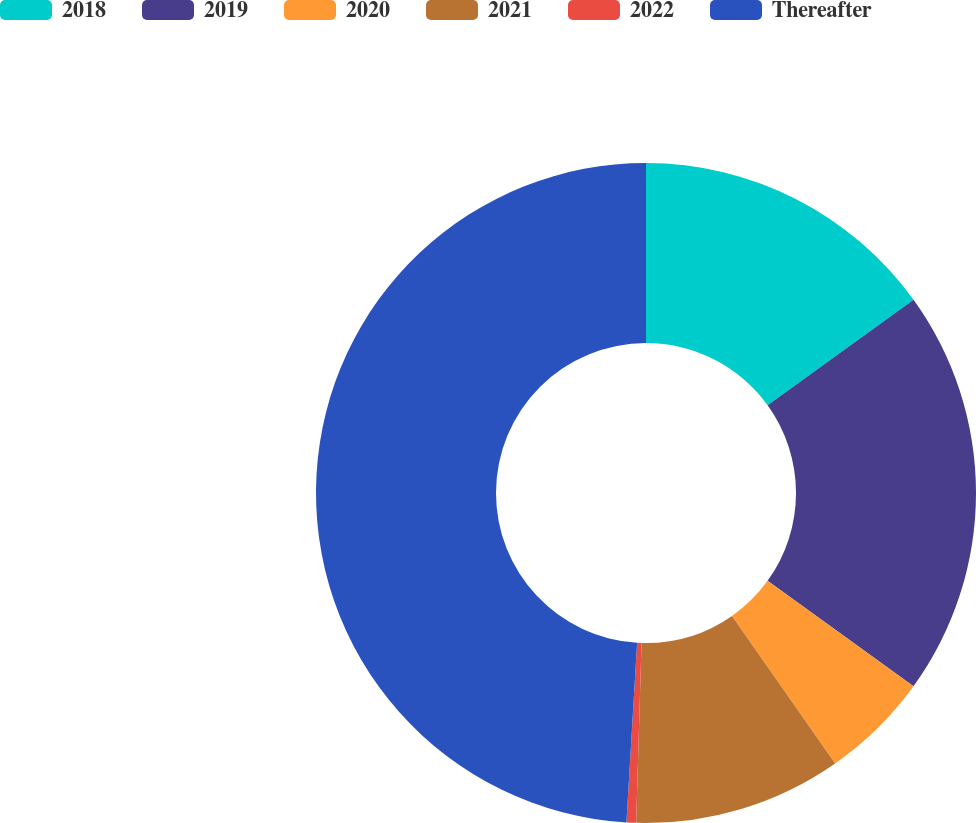<chart> <loc_0><loc_0><loc_500><loc_500><pie_chart><fcel>2018<fcel>2019<fcel>2020<fcel>2021<fcel>2022<fcel>Thereafter<nl><fcel>15.05%<fcel>19.91%<fcel>5.33%<fcel>10.19%<fcel>0.47%<fcel>49.06%<nl></chart> 